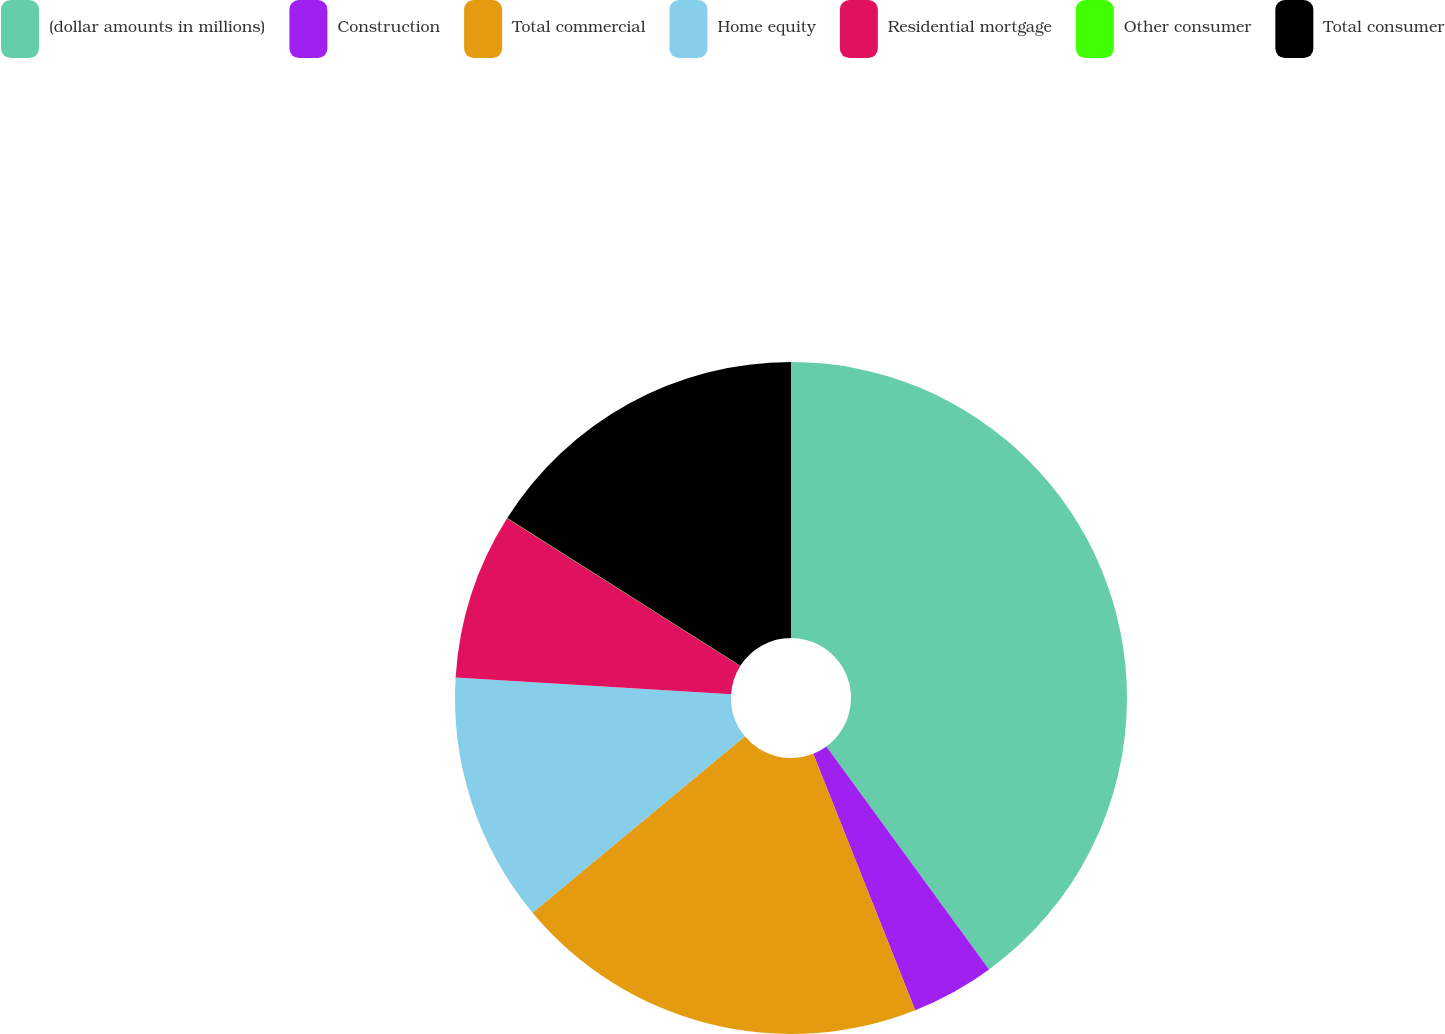<chart> <loc_0><loc_0><loc_500><loc_500><pie_chart><fcel>(dollar amounts in millions)<fcel>Construction<fcel>Total commercial<fcel>Home equity<fcel>Residential mortgage<fcel>Other consumer<fcel>Total consumer<nl><fcel>39.96%<fcel>4.01%<fcel>19.99%<fcel>12.0%<fcel>8.01%<fcel>0.02%<fcel>16.0%<nl></chart> 